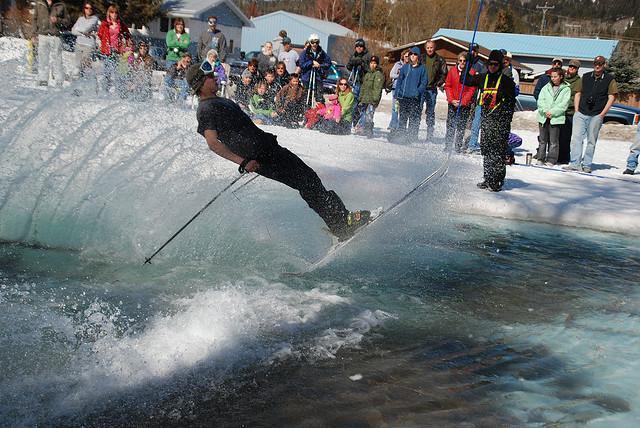How many people are visible?
Give a very brief answer. 4. How many boats can you see in the water?
Give a very brief answer. 0. 